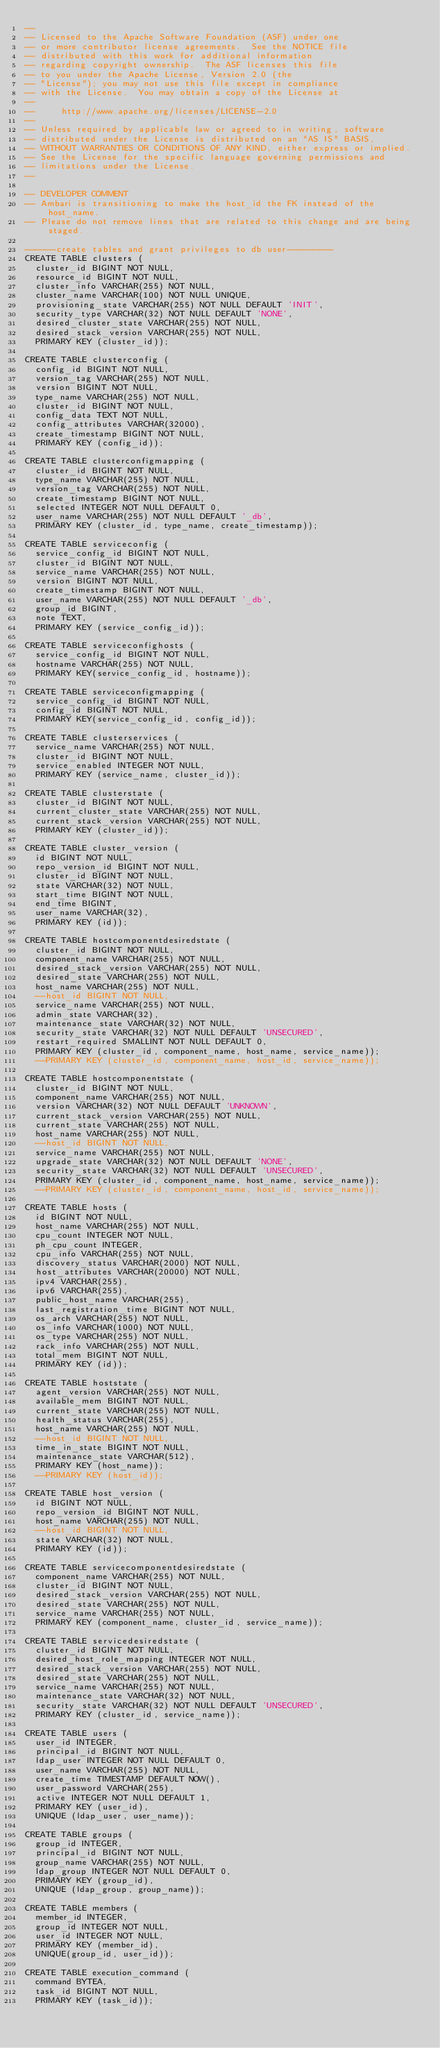Convert code to text. <code><loc_0><loc_0><loc_500><loc_500><_SQL_>--
-- Licensed to the Apache Software Foundation (ASF) under one
-- or more contributor license agreements.  See the NOTICE file
-- distributed with this work for additional information
-- regarding copyright ownership.  The ASF licenses this file
-- to you under the Apache License, Version 2.0 (the
-- "License"); you may not use this file except in compliance
-- with the License.  You may obtain a copy of the License at
--
--     http://www.apache.org/licenses/LICENSE-2.0
--
-- Unless required by applicable law or agreed to in writing, software
-- distributed under the License is distributed on an "AS IS" BASIS,
-- WITHOUT WARRANTIES OR CONDITIONS OF ANY KIND, either express or implied.
-- See the License for the specific language governing permissions and
-- limitations under the License.
--

-- DEVELOPER COMMENT
-- Ambari is transitioning to make the host_id the FK instead of the host_name.
-- Please do not remove lines that are related to this change and are being staged.

------create tables and grant privileges to db user---------
CREATE TABLE clusters (
  cluster_id BIGINT NOT NULL,
  resource_id BIGINT NOT NULL,
  cluster_info VARCHAR(255) NOT NULL,
  cluster_name VARCHAR(100) NOT NULL UNIQUE,
  provisioning_state VARCHAR(255) NOT NULL DEFAULT 'INIT',
  security_type VARCHAR(32) NOT NULL DEFAULT 'NONE',
  desired_cluster_state VARCHAR(255) NOT NULL,
  desired_stack_version VARCHAR(255) NOT NULL,
  PRIMARY KEY (cluster_id));

CREATE TABLE clusterconfig (
  config_id BIGINT NOT NULL,
  version_tag VARCHAR(255) NOT NULL,
  version BIGINT NOT NULL,
  type_name VARCHAR(255) NOT NULL,
  cluster_id BIGINT NOT NULL,
  config_data TEXT NOT NULL,
  config_attributes VARCHAR(32000),
  create_timestamp BIGINT NOT NULL,
  PRIMARY KEY (config_id));

CREATE TABLE clusterconfigmapping (
  cluster_id BIGINT NOT NULL,
  type_name VARCHAR(255) NOT NULL,
  version_tag VARCHAR(255) NOT NULL,
  create_timestamp BIGINT NOT NULL,
  selected INTEGER NOT NULL DEFAULT 0,
  user_name VARCHAR(255) NOT NULL DEFAULT '_db',
  PRIMARY KEY (cluster_id, type_name, create_timestamp));

CREATE TABLE serviceconfig (
  service_config_id BIGINT NOT NULL,
  cluster_id BIGINT NOT NULL,
  service_name VARCHAR(255) NOT NULL,
  version BIGINT NOT NULL,
  create_timestamp BIGINT NOT NULL,
  user_name VARCHAR(255) NOT NULL DEFAULT '_db',
  group_id BIGINT,
  note TEXT,
  PRIMARY KEY (service_config_id));

CREATE TABLE serviceconfighosts (
  service_config_id BIGINT NOT NULL,
  hostname VARCHAR(255) NOT NULL,
  PRIMARY KEY(service_config_id, hostname));

CREATE TABLE serviceconfigmapping (
  service_config_id BIGINT NOT NULL,
  config_id BIGINT NOT NULL,
  PRIMARY KEY(service_config_id, config_id));

CREATE TABLE clusterservices (
  service_name VARCHAR(255) NOT NULL,
  cluster_id BIGINT NOT NULL,
  service_enabled INTEGER NOT NULL,
  PRIMARY KEY (service_name, cluster_id));

CREATE TABLE clusterstate (
  cluster_id BIGINT NOT NULL,
  current_cluster_state VARCHAR(255) NOT NULL,
  current_stack_version VARCHAR(255) NOT NULL,
  PRIMARY KEY (cluster_id));

CREATE TABLE cluster_version (
  id BIGINT NOT NULL,
  repo_version_id BIGINT NOT NULL,
  cluster_id BIGINT NOT NULL,
  state VARCHAR(32) NOT NULL,
  start_time BIGINT NOT NULL,
  end_time BIGINT,
  user_name VARCHAR(32),
  PRIMARY KEY (id));

CREATE TABLE hostcomponentdesiredstate (
  cluster_id BIGINT NOT NULL,
  component_name VARCHAR(255) NOT NULL,
  desired_stack_version VARCHAR(255) NOT NULL,
  desired_state VARCHAR(255) NOT NULL,
  host_name VARCHAR(255) NOT NULL,
  --host_id BIGINT NOT NULL,
  service_name VARCHAR(255) NOT NULL,
  admin_state VARCHAR(32),
  maintenance_state VARCHAR(32) NOT NULL,
  security_state VARCHAR(32) NOT NULL DEFAULT 'UNSECURED',
  restart_required SMALLINT NOT NULL DEFAULT 0,
  PRIMARY KEY (cluster_id, component_name, host_name, service_name));
  --PRIMARY KEY (cluster_id, component_name, host_id, service_name));

CREATE TABLE hostcomponentstate (
  cluster_id BIGINT NOT NULL,
  component_name VARCHAR(255) NOT NULL,
  version VARCHAR(32) NOT NULL DEFAULT 'UNKNOWN',
  current_stack_version VARCHAR(255) NOT NULL,
  current_state VARCHAR(255) NOT NULL,
  host_name VARCHAR(255) NOT NULL,
  --host_id BIGINT NOT NULL,
  service_name VARCHAR(255) NOT NULL,
  upgrade_state VARCHAR(32) NOT NULL DEFAULT 'NONE',
  security_state VARCHAR(32) NOT NULL DEFAULT 'UNSECURED',
  PRIMARY KEY (cluster_id, component_name, host_name, service_name));
  --PRIMARY KEY (cluster_id, component_name, host_id, service_name));

CREATE TABLE hosts (
  id BIGINT NOT NULL,
  host_name VARCHAR(255) NOT NULL,
  cpu_count INTEGER NOT NULL,
  ph_cpu_count INTEGER,
  cpu_info VARCHAR(255) NOT NULL,
  discovery_status VARCHAR(2000) NOT NULL,
  host_attributes VARCHAR(20000) NOT NULL,
  ipv4 VARCHAR(255),
  ipv6 VARCHAR(255),
  public_host_name VARCHAR(255),
  last_registration_time BIGINT NOT NULL,
  os_arch VARCHAR(255) NOT NULL,
  os_info VARCHAR(1000) NOT NULL,
  os_type VARCHAR(255) NOT NULL,
  rack_info VARCHAR(255) NOT NULL,
  total_mem BIGINT NOT NULL,
  PRIMARY KEY (id));

CREATE TABLE hoststate (
  agent_version VARCHAR(255) NOT NULL,
  available_mem BIGINT NOT NULL,
  current_state VARCHAR(255) NOT NULL,
  health_status VARCHAR(255),
  host_name VARCHAR(255) NOT NULL,
  --host_id BIGINT NOT NULL,
  time_in_state BIGINT NOT NULL,
  maintenance_state VARCHAR(512),
  PRIMARY KEY (host_name));
  --PRIMARY KEY (host_id));

CREATE TABLE host_version (
  id BIGINT NOT NULL,
  repo_version_id BIGINT NOT NULL,
  host_name VARCHAR(255) NOT NULL,
  --host_id BIGINT NOT NULL,
  state VARCHAR(32) NOT NULL,
  PRIMARY KEY (id));

CREATE TABLE servicecomponentdesiredstate (
  component_name VARCHAR(255) NOT NULL,
  cluster_id BIGINT NOT NULL,
  desired_stack_version VARCHAR(255) NOT NULL,
  desired_state VARCHAR(255) NOT NULL,
  service_name VARCHAR(255) NOT NULL,
  PRIMARY KEY (component_name, cluster_id, service_name));

CREATE TABLE servicedesiredstate (
  cluster_id BIGINT NOT NULL,
  desired_host_role_mapping INTEGER NOT NULL,
  desired_stack_version VARCHAR(255) NOT NULL,
  desired_state VARCHAR(255) NOT NULL,
  service_name VARCHAR(255) NOT NULL,
  maintenance_state VARCHAR(32) NOT NULL,
  security_state VARCHAR(32) NOT NULL DEFAULT 'UNSECURED',
  PRIMARY KEY (cluster_id, service_name));

CREATE TABLE users (
  user_id INTEGER,
  principal_id BIGINT NOT NULL,
  ldap_user INTEGER NOT NULL DEFAULT 0,
  user_name VARCHAR(255) NOT NULL,
  create_time TIMESTAMP DEFAULT NOW(),
  user_password VARCHAR(255),
  active INTEGER NOT NULL DEFAULT 1,
  PRIMARY KEY (user_id),
  UNIQUE (ldap_user, user_name));

CREATE TABLE groups (
  group_id INTEGER,
  principal_id BIGINT NOT NULL,
  group_name VARCHAR(255) NOT NULL,
  ldap_group INTEGER NOT NULL DEFAULT 0,
  PRIMARY KEY (group_id),
  UNIQUE (ldap_group, group_name));

CREATE TABLE members (
  member_id INTEGER,
  group_id INTEGER NOT NULL,
  user_id INTEGER NOT NULL,
  PRIMARY KEY (member_id),
  UNIQUE(group_id, user_id));

CREATE TABLE execution_command (
  command BYTEA,
  task_id BIGINT NOT NULL,
  PRIMARY KEY (task_id));
</code> 